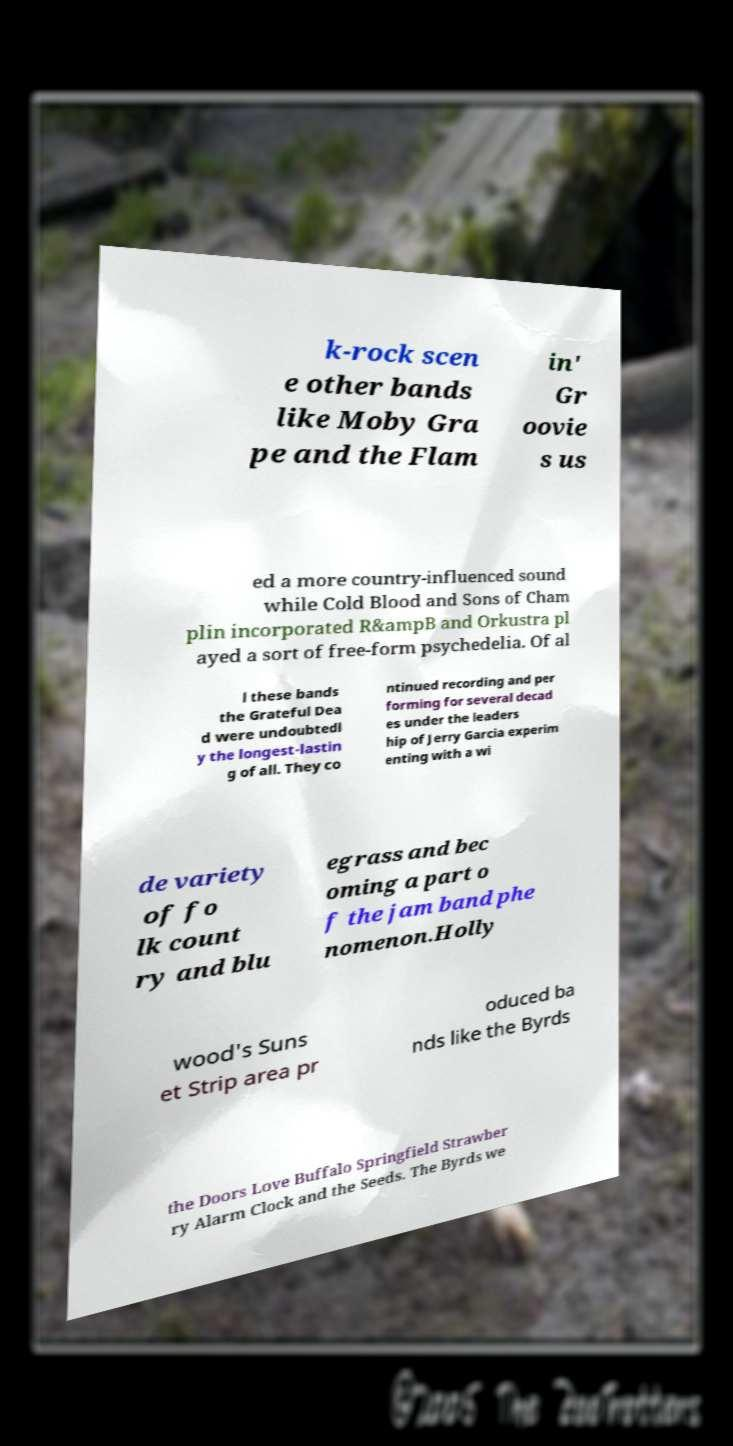There's text embedded in this image that I need extracted. Can you transcribe it verbatim? k-rock scen e other bands like Moby Gra pe and the Flam in' Gr oovie s us ed a more country-influenced sound while Cold Blood and Sons of Cham plin incorporated R&ampB and Orkustra pl ayed a sort of free-form psychedelia. Of al l these bands the Grateful Dea d were undoubtedl y the longest-lastin g of all. They co ntinued recording and per forming for several decad es under the leaders hip of Jerry Garcia experim enting with a wi de variety of fo lk count ry and blu egrass and bec oming a part o f the jam band phe nomenon.Holly wood's Suns et Strip area pr oduced ba nds like the Byrds the Doors Love Buffalo Springfield Strawber ry Alarm Clock and the Seeds. The Byrds we 